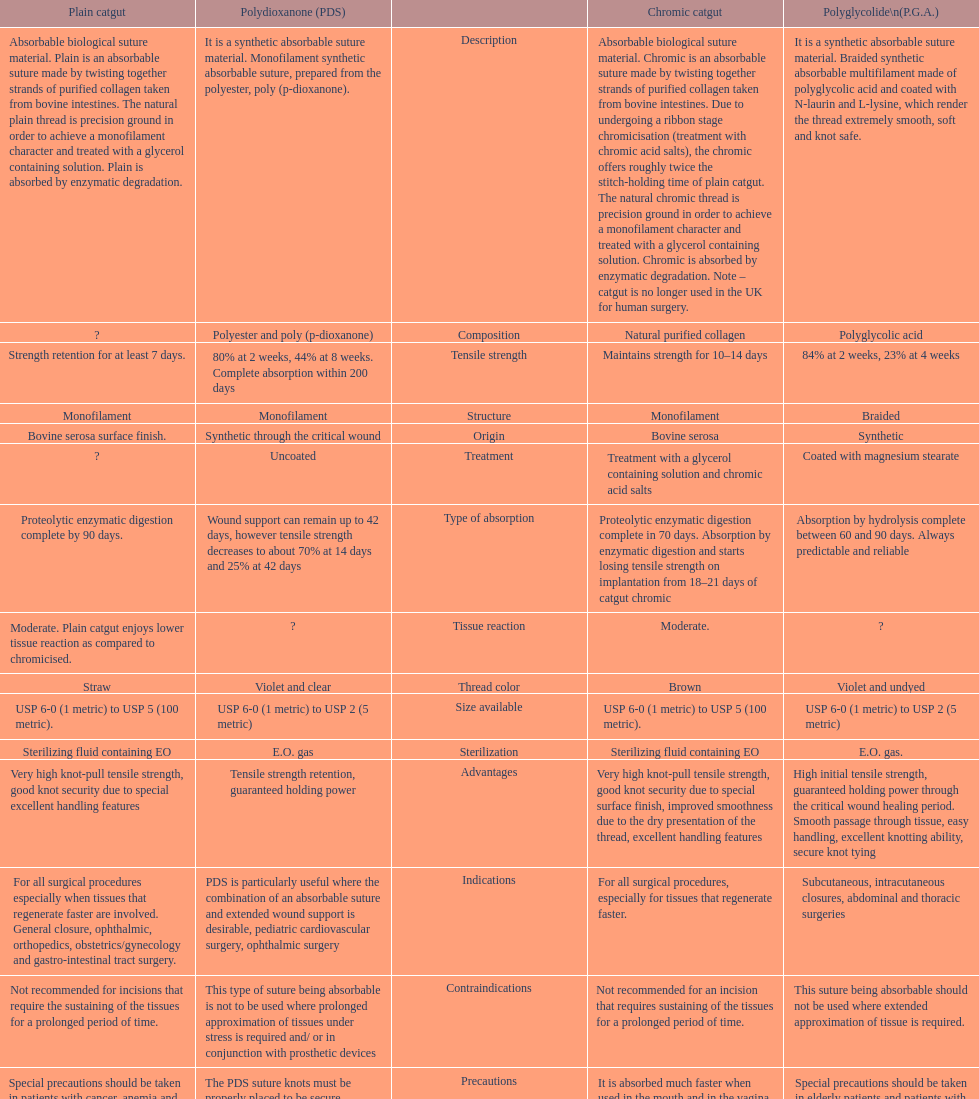How long does a chromic catgut maintain it's strength for 10-14 days. 